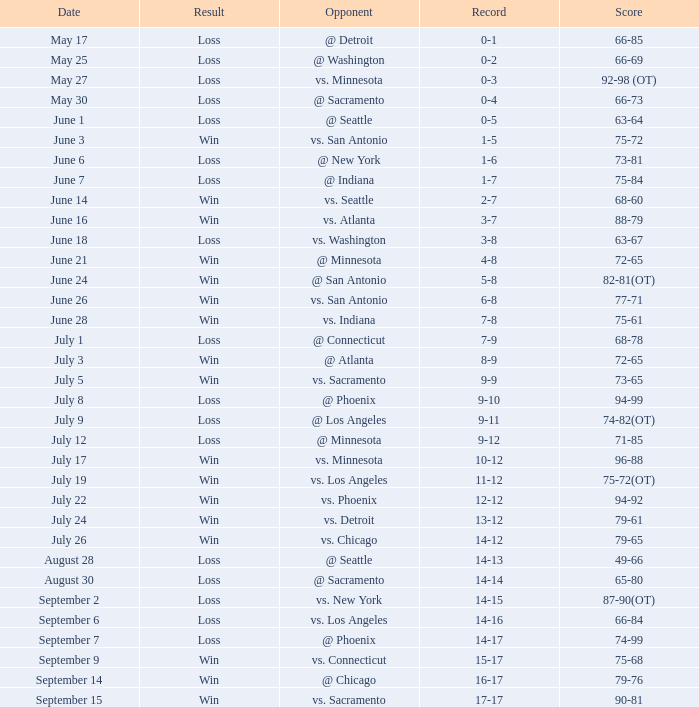What was the Result on July 24? Win. 